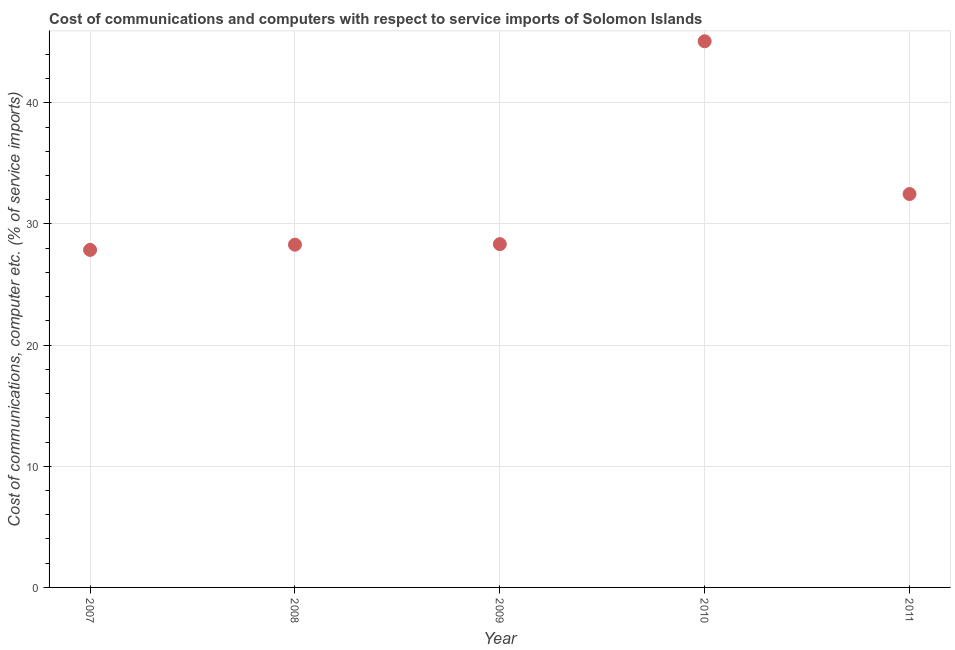What is the cost of communications and computer in 2008?
Give a very brief answer. 28.29. Across all years, what is the maximum cost of communications and computer?
Your answer should be very brief. 45.08. Across all years, what is the minimum cost of communications and computer?
Provide a succinct answer. 27.86. In which year was the cost of communications and computer minimum?
Your response must be concise. 2007. What is the sum of the cost of communications and computer?
Give a very brief answer. 162.04. What is the difference between the cost of communications and computer in 2010 and 2011?
Ensure brevity in your answer.  12.61. What is the average cost of communications and computer per year?
Provide a short and direct response. 32.41. What is the median cost of communications and computer?
Offer a terse response. 28.34. In how many years, is the cost of communications and computer greater than 6 %?
Keep it short and to the point. 5. What is the ratio of the cost of communications and computer in 2007 to that in 2008?
Ensure brevity in your answer.  0.98. Is the difference between the cost of communications and computer in 2008 and 2009 greater than the difference between any two years?
Provide a succinct answer. No. What is the difference between the highest and the second highest cost of communications and computer?
Give a very brief answer. 12.61. What is the difference between the highest and the lowest cost of communications and computer?
Ensure brevity in your answer.  17.22. In how many years, is the cost of communications and computer greater than the average cost of communications and computer taken over all years?
Make the answer very short. 2. How many years are there in the graph?
Give a very brief answer. 5. Are the values on the major ticks of Y-axis written in scientific E-notation?
Give a very brief answer. No. Does the graph contain grids?
Make the answer very short. Yes. What is the title of the graph?
Give a very brief answer. Cost of communications and computers with respect to service imports of Solomon Islands. What is the label or title of the X-axis?
Offer a very short reply. Year. What is the label or title of the Y-axis?
Your answer should be compact. Cost of communications, computer etc. (% of service imports). What is the Cost of communications, computer etc. (% of service imports) in 2007?
Your answer should be compact. 27.86. What is the Cost of communications, computer etc. (% of service imports) in 2008?
Keep it short and to the point. 28.29. What is the Cost of communications, computer etc. (% of service imports) in 2009?
Give a very brief answer. 28.34. What is the Cost of communications, computer etc. (% of service imports) in 2010?
Make the answer very short. 45.08. What is the Cost of communications, computer etc. (% of service imports) in 2011?
Your answer should be very brief. 32.47. What is the difference between the Cost of communications, computer etc. (% of service imports) in 2007 and 2008?
Provide a succinct answer. -0.43. What is the difference between the Cost of communications, computer etc. (% of service imports) in 2007 and 2009?
Provide a succinct answer. -0.47. What is the difference between the Cost of communications, computer etc. (% of service imports) in 2007 and 2010?
Your answer should be compact. -17.22. What is the difference between the Cost of communications, computer etc. (% of service imports) in 2007 and 2011?
Make the answer very short. -4.61. What is the difference between the Cost of communications, computer etc. (% of service imports) in 2008 and 2009?
Provide a short and direct response. -0.04. What is the difference between the Cost of communications, computer etc. (% of service imports) in 2008 and 2010?
Your answer should be very brief. -16.79. What is the difference between the Cost of communications, computer etc. (% of service imports) in 2008 and 2011?
Give a very brief answer. -4.18. What is the difference between the Cost of communications, computer etc. (% of service imports) in 2009 and 2010?
Offer a terse response. -16.75. What is the difference between the Cost of communications, computer etc. (% of service imports) in 2009 and 2011?
Offer a very short reply. -4.14. What is the difference between the Cost of communications, computer etc. (% of service imports) in 2010 and 2011?
Offer a very short reply. 12.61. What is the ratio of the Cost of communications, computer etc. (% of service imports) in 2007 to that in 2010?
Your response must be concise. 0.62. What is the ratio of the Cost of communications, computer etc. (% of service imports) in 2007 to that in 2011?
Your answer should be compact. 0.86. What is the ratio of the Cost of communications, computer etc. (% of service imports) in 2008 to that in 2009?
Your response must be concise. 1. What is the ratio of the Cost of communications, computer etc. (% of service imports) in 2008 to that in 2010?
Provide a succinct answer. 0.63. What is the ratio of the Cost of communications, computer etc. (% of service imports) in 2008 to that in 2011?
Give a very brief answer. 0.87. What is the ratio of the Cost of communications, computer etc. (% of service imports) in 2009 to that in 2010?
Offer a very short reply. 0.63. What is the ratio of the Cost of communications, computer etc. (% of service imports) in 2009 to that in 2011?
Your answer should be compact. 0.87. What is the ratio of the Cost of communications, computer etc. (% of service imports) in 2010 to that in 2011?
Give a very brief answer. 1.39. 